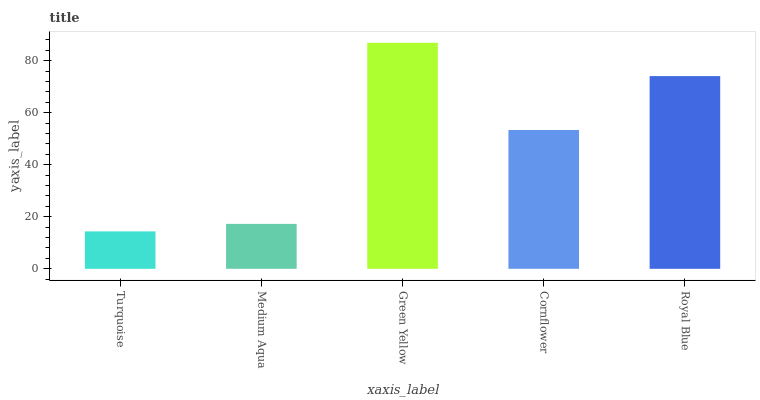Is Turquoise the minimum?
Answer yes or no. Yes. Is Green Yellow the maximum?
Answer yes or no. Yes. Is Medium Aqua the minimum?
Answer yes or no. No. Is Medium Aqua the maximum?
Answer yes or no. No. Is Medium Aqua greater than Turquoise?
Answer yes or no. Yes. Is Turquoise less than Medium Aqua?
Answer yes or no. Yes. Is Turquoise greater than Medium Aqua?
Answer yes or no. No. Is Medium Aqua less than Turquoise?
Answer yes or no. No. Is Cornflower the high median?
Answer yes or no. Yes. Is Cornflower the low median?
Answer yes or no. Yes. Is Green Yellow the high median?
Answer yes or no. No. Is Green Yellow the low median?
Answer yes or no. No. 